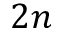Convert formula to latex. <formula><loc_0><loc_0><loc_500><loc_500>2 n</formula> 